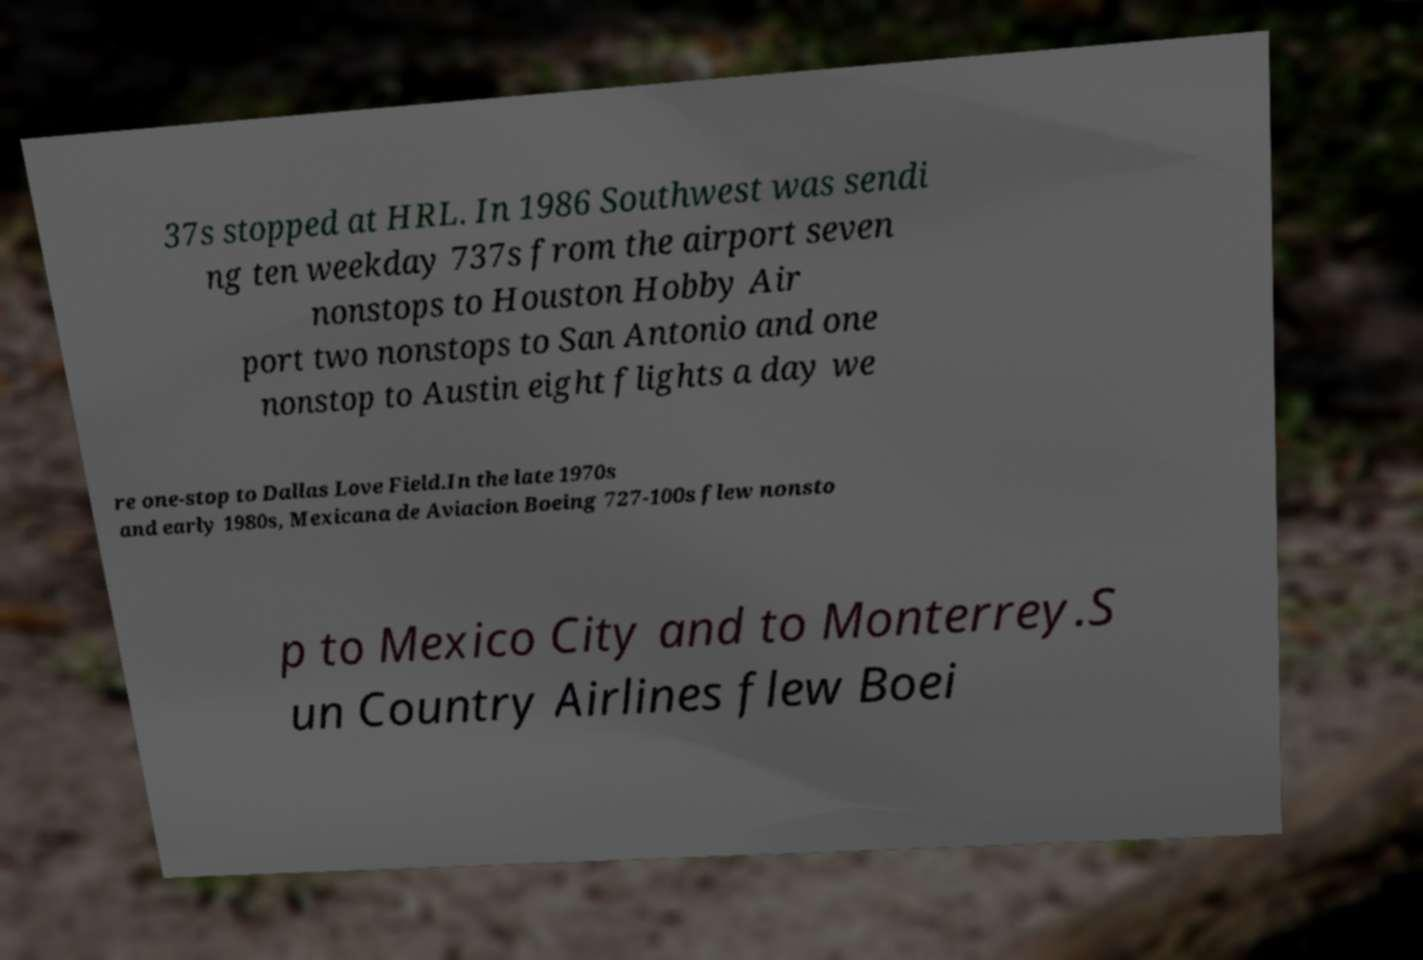Please identify and transcribe the text found in this image. 37s stopped at HRL. In 1986 Southwest was sendi ng ten weekday 737s from the airport seven nonstops to Houston Hobby Air port two nonstops to San Antonio and one nonstop to Austin eight flights a day we re one-stop to Dallas Love Field.In the late 1970s and early 1980s, Mexicana de Aviacion Boeing 727-100s flew nonsto p to Mexico City and to Monterrey.S un Country Airlines flew Boei 